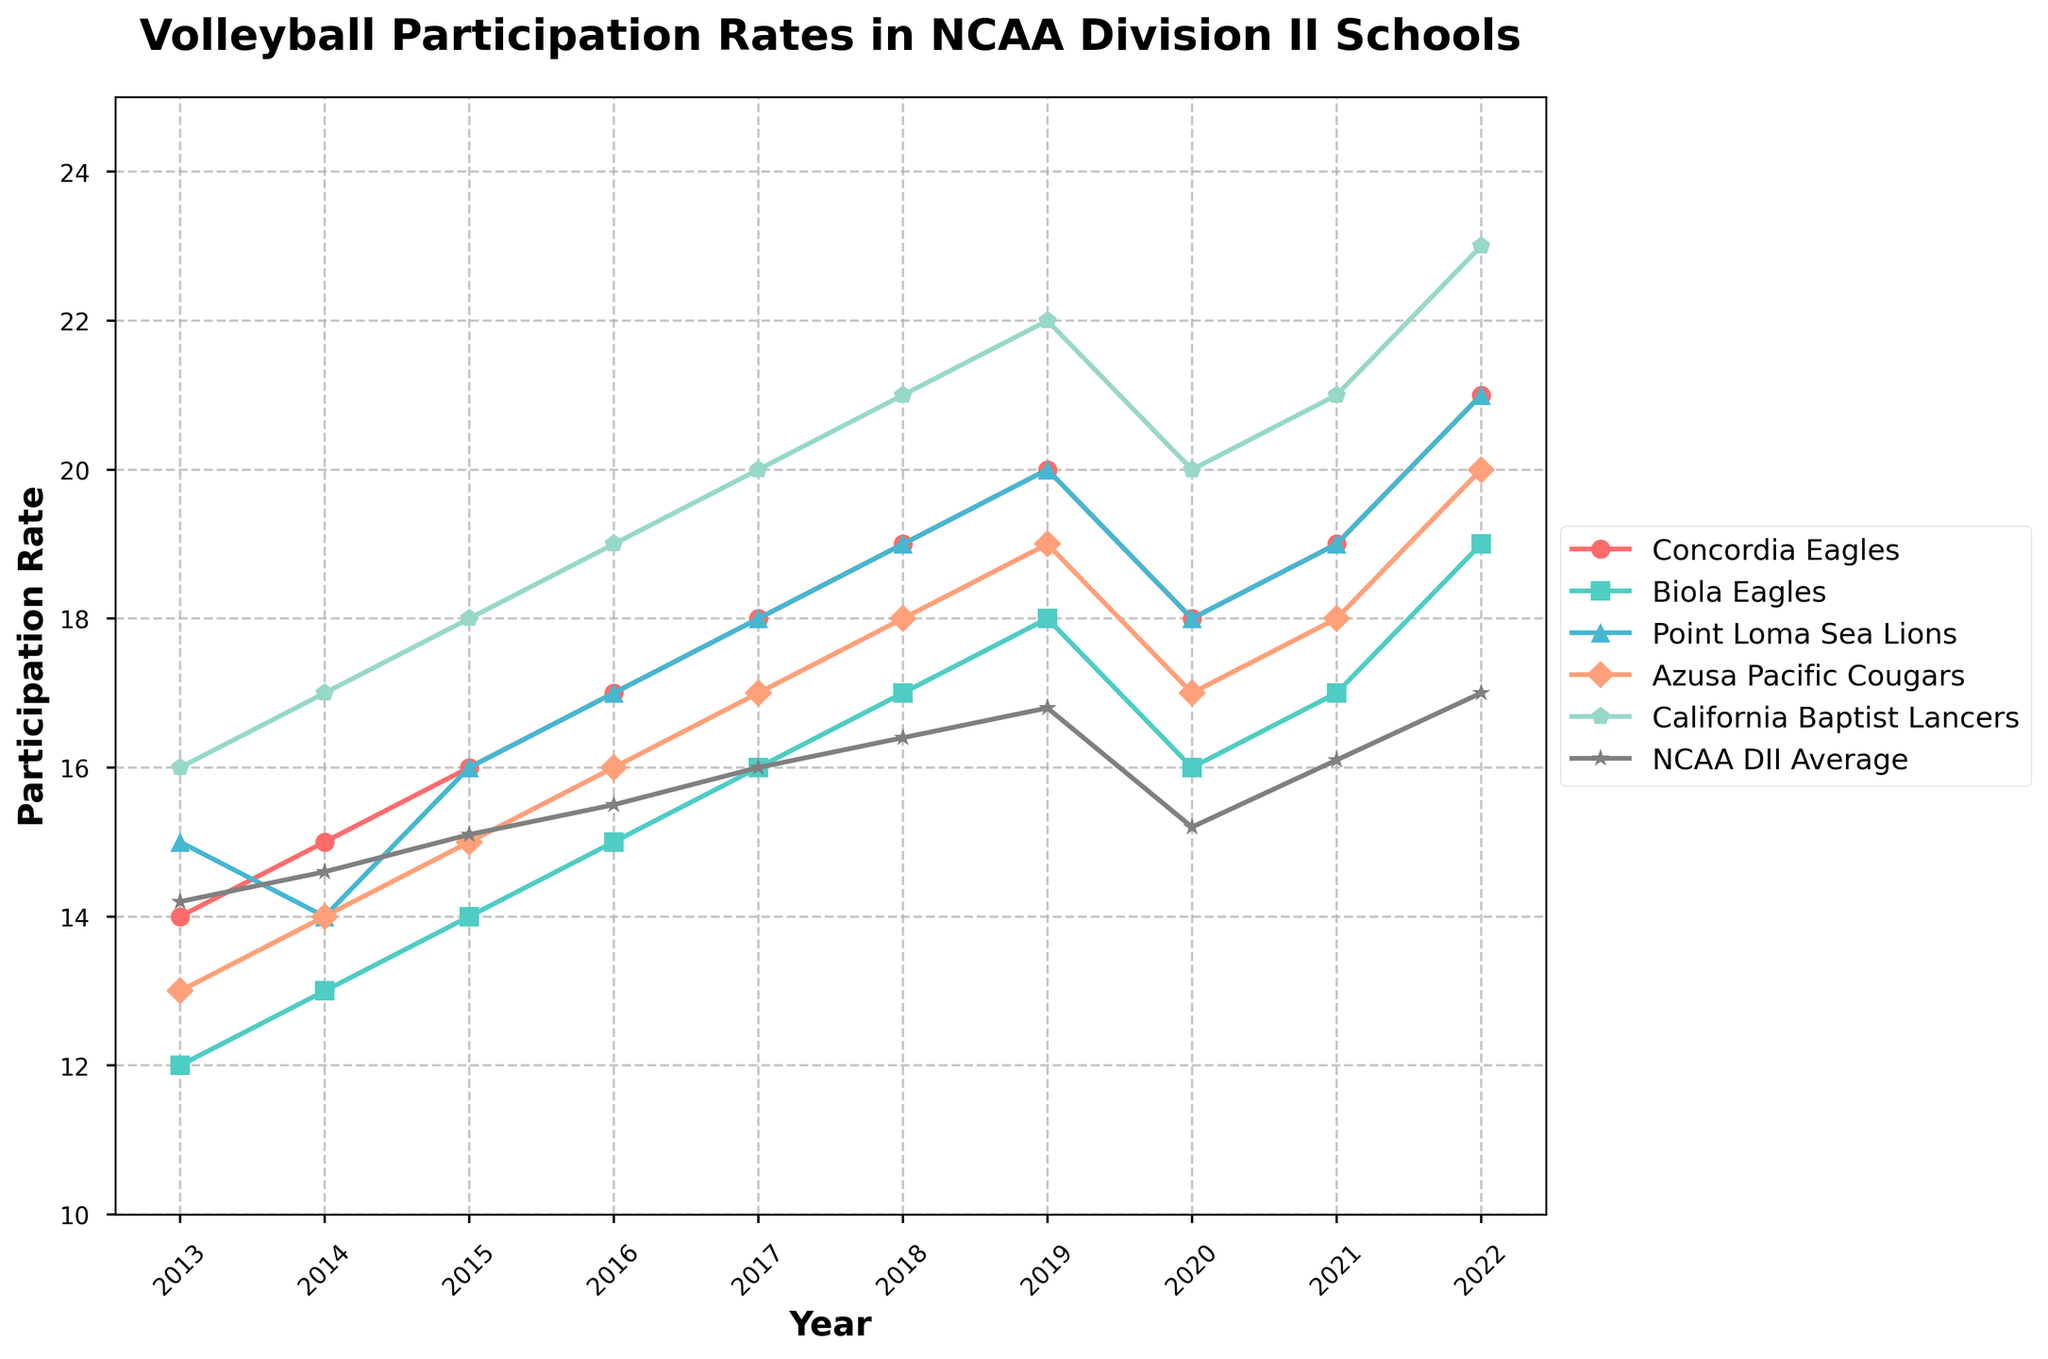What is the overall trend in the participation rates of the Concordia Eagles over the decade? Looking at the plot, the Concordia Eagles' participation rates show an upward trend starting at 14 in 2013 and gradually increasing to 21 by 2022.
Answer: Upward trend How does the participation rate of the California Baptist Lancers in 2015 compare to their rate in 2019? In 2015, the California Baptist Lancers had a participation rate of 18, and in 2019, it was 22. Therefore, their rate increased by 4 from 2015 to 2019.
Answer: Increased by 4 Which team had the highest participation rate in 2022, and what was it? In 2022, the California Baptist Lancers had the highest participation rate among the teams, which was 23.
Answer: California Baptist Lancers, 23 In which year did the NCAA DII average participation rate drop, and by how much did it drop compared to the previous year? The NCAA DII average participation rate dropped in 2020 from 16.8 in 2019 to 15.2 in 2020, representing a drop of 1.6.
Answer: 2020, dropped by 1.6 Compare the participation rates of the Biola Eagles and the Point Loma Sea Lions in 2018. Which team had a higher rate and by how much? In 2018, the Biola Eagles had a participation rate of 17, whereas the Point Loma Sea Lions had a rate of 19. Therefore, the Point Loma Sea Lions had a higher rate by 2.
Answer: Point Loma Sea Lions, 2 Which year did the Azusa Pacific Cougars and the Concordia Eagles have the same participation rate, and what was the rate? In 2020, both the Azusa Pacific Cougars and the Concordia Eagles had the same participation rate of 18.
Answer: 2020, 18 What is the visual indication that shows the NCAA DII Average in the plot? The NCAA DII Average is represented by a gray line with a star marker throughout the plot.
Answer: Gray line with a star marker Calculate the average participation rate for the Concordia Eagles over the decade. The participation rates for the Concordia Eagles over the decade are: 14, 15, 16, 17, 18, 19, 20, 18, 19, 21. Summing them up gives 177, and dividing by 10 gives an average of 17.7
Answer: 17.7 Which year had the least difference in participation rates between the Concordia Eagles and Biola Eagles, and what was the difference? In 2013, the Concordia Eagles' rate was 14 and Biola Eagles' was 12, with a difference of 2, which is the smallest difference observed.
Answer: 2013, 2 For which team did the participation rate show a consistent increase from 2013 to 2019? The Point Loma Sea Lions showed a consistent increase in participation rates from 15 in 2013 to 20 in 2019.
Answer: Point Loma Sea Lions 